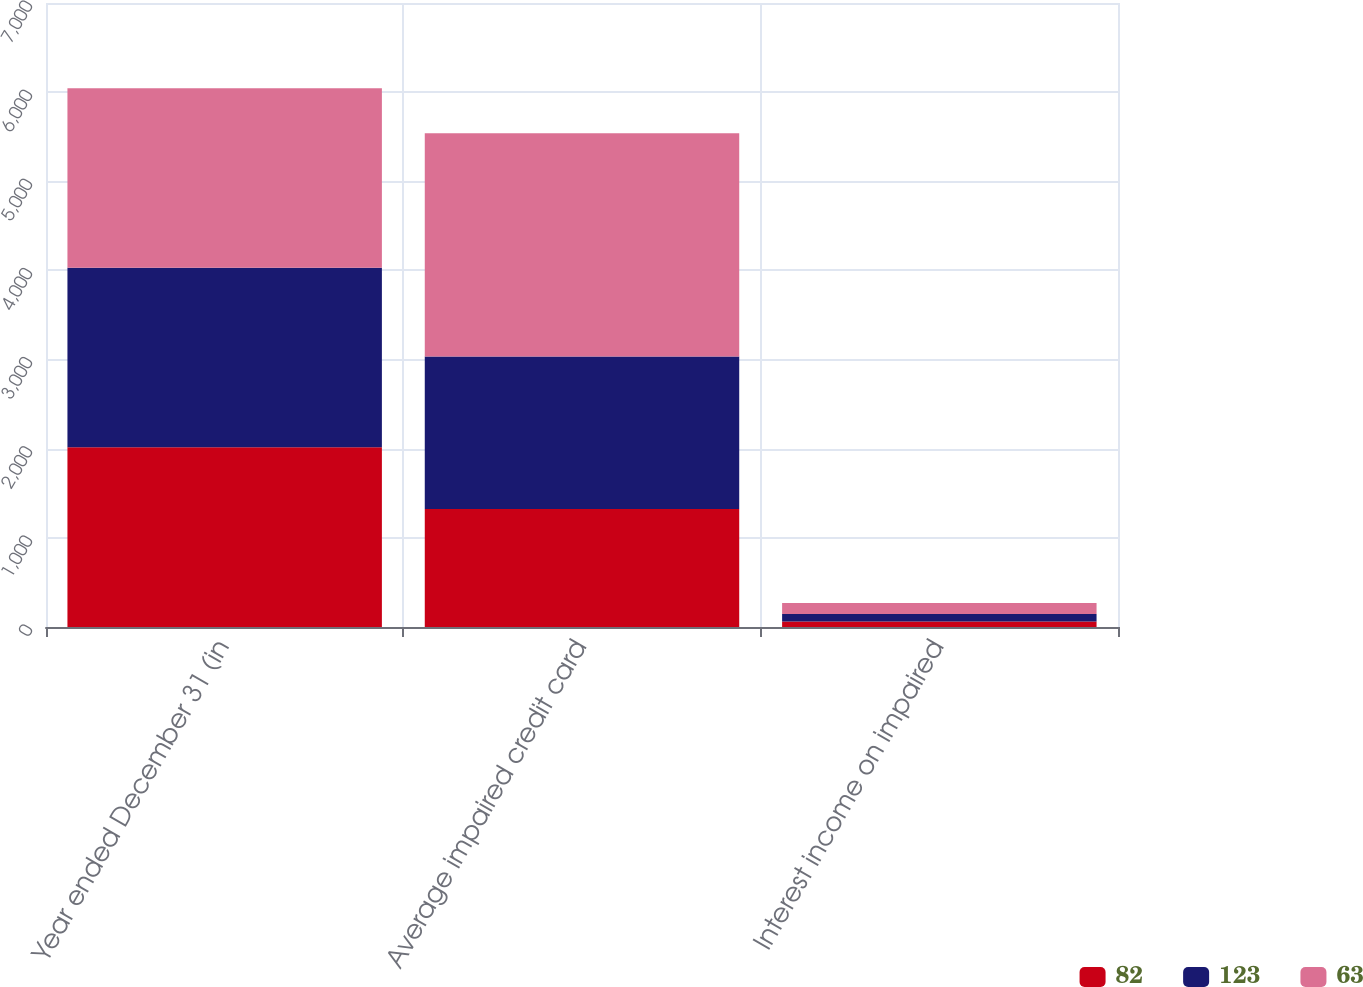Convert chart to OTSL. <chart><loc_0><loc_0><loc_500><loc_500><stacked_bar_chart><ecel><fcel>Year ended December 31 (in<fcel>Average impaired credit card<fcel>Interest income on impaired<nl><fcel>82<fcel>2016<fcel>1325<fcel>63<nl><fcel>123<fcel>2015<fcel>1710<fcel>82<nl><fcel>63<fcel>2014<fcel>2503<fcel>123<nl></chart> 